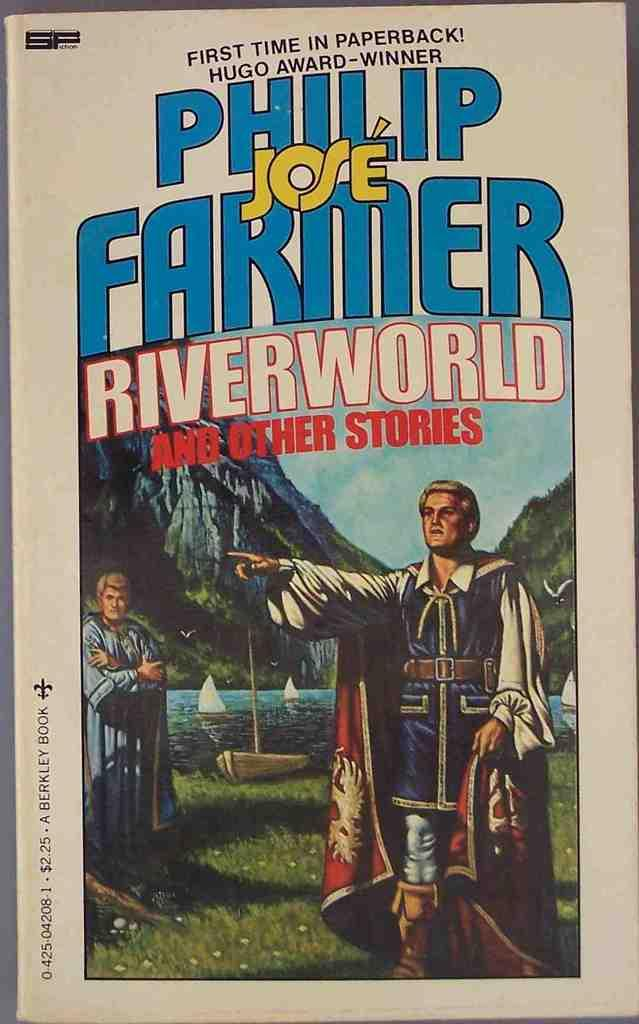<image>
Share a concise interpretation of the image provided. paperback copy of book named phillip jose farmer riverworld and other stories 